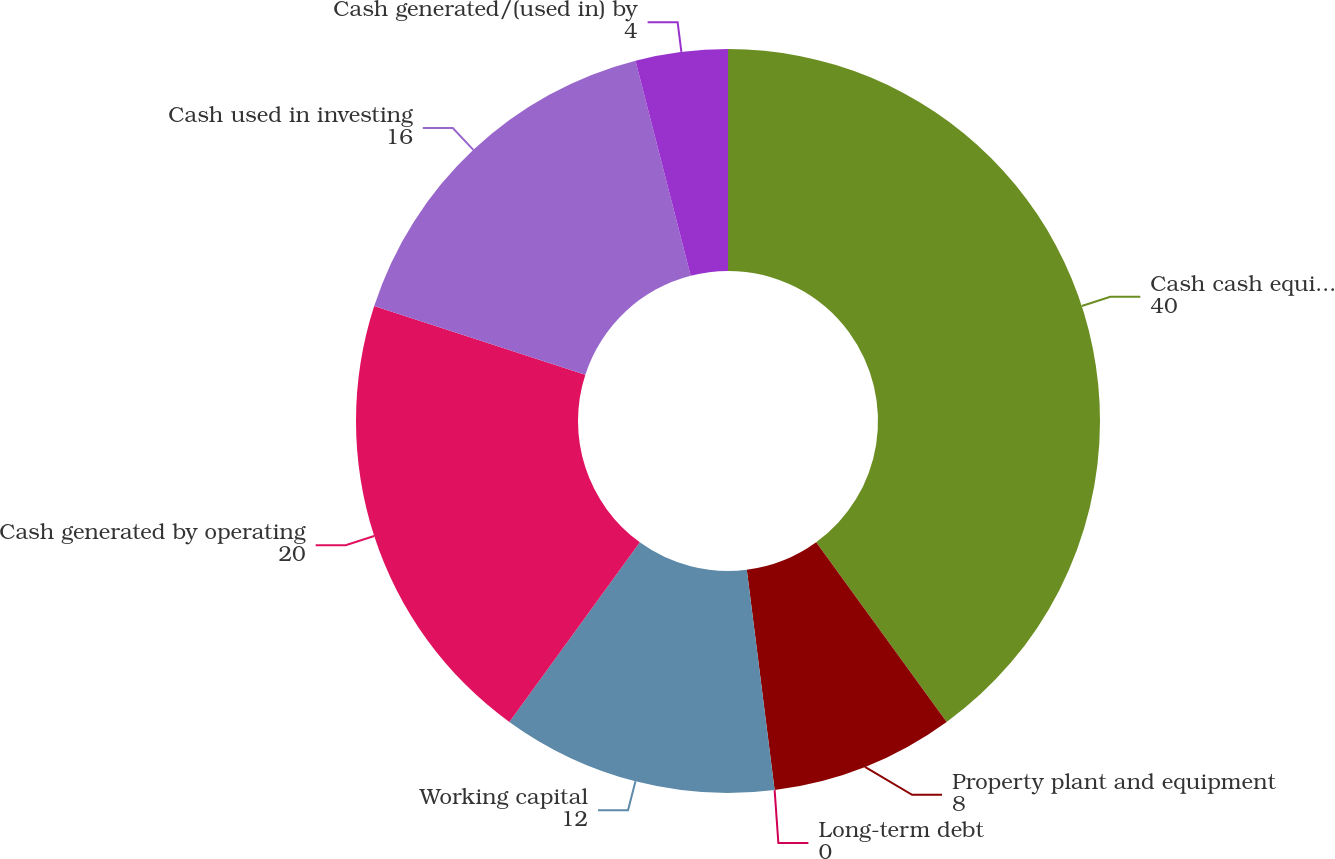Convert chart to OTSL. <chart><loc_0><loc_0><loc_500><loc_500><pie_chart><fcel>Cash cash equivalents and<fcel>Property plant and equipment<fcel>Long-term debt<fcel>Working capital<fcel>Cash generated by operating<fcel>Cash used in investing<fcel>Cash generated/(used in) by<nl><fcel>40.0%<fcel>8.0%<fcel>0.0%<fcel>12.0%<fcel>20.0%<fcel>16.0%<fcel>4.0%<nl></chart> 